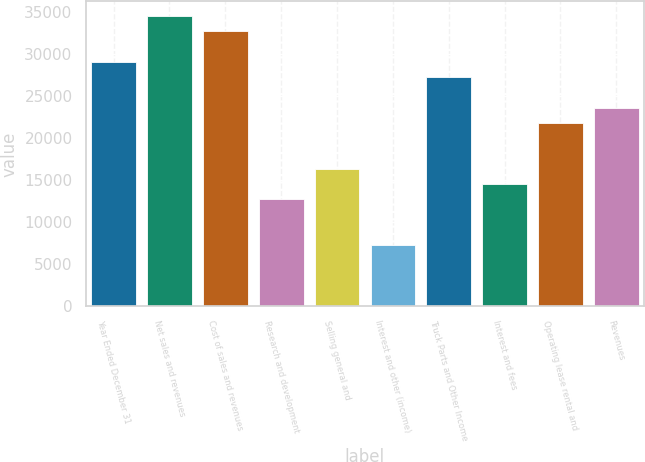Convert chart. <chart><loc_0><loc_0><loc_500><loc_500><bar_chart><fcel>Year Ended December 31<fcel>Net sales and revenues<fcel>Cost of sales and revenues<fcel>Research and development<fcel>Selling general and<fcel>Interest and other (income)<fcel>Truck Parts and Other Income<fcel>Interest and fees<fcel>Operating lease rental and<fcel>Revenues<nl><fcel>29097.2<fcel>34552<fcel>32733.7<fcel>12732.7<fcel>16369.2<fcel>7277.86<fcel>27278.9<fcel>14551<fcel>21824.1<fcel>23642.3<nl></chart> 